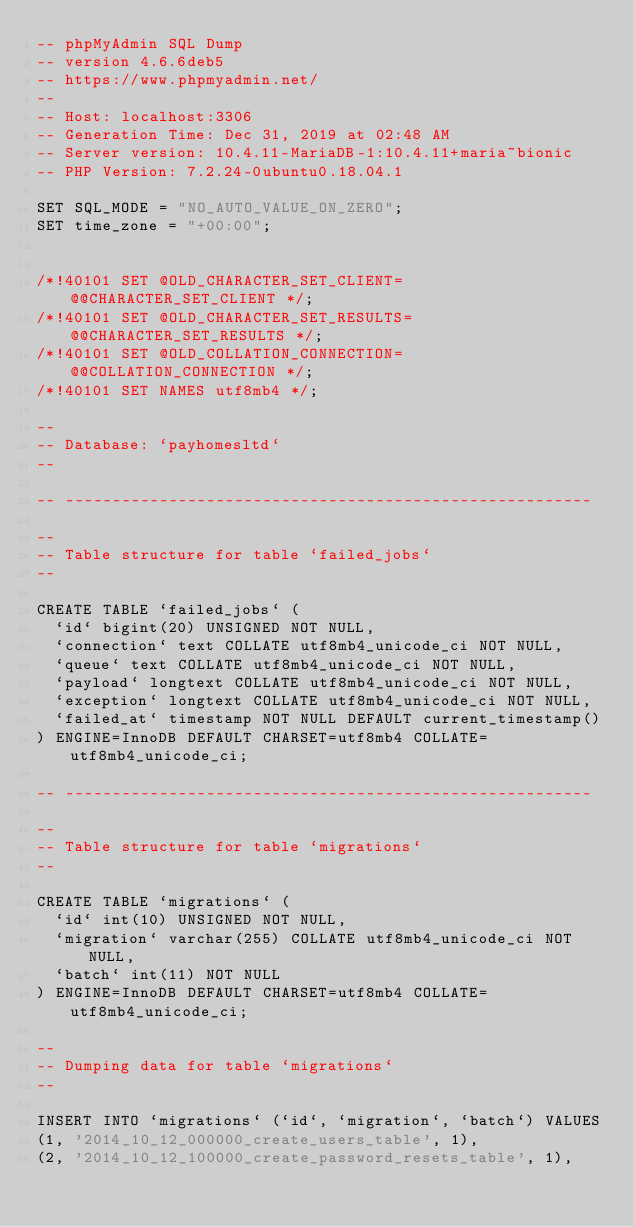<code> <loc_0><loc_0><loc_500><loc_500><_SQL_>-- phpMyAdmin SQL Dump
-- version 4.6.6deb5
-- https://www.phpmyadmin.net/
--
-- Host: localhost:3306
-- Generation Time: Dec 31, 2019 at 02:48 AM
-- Server version: 10.4.11-MariaDB-1:10.4.11+maria~bionic
-- PHP Version: 7.2.24-0ubuntu0.18.04.1

SET SQL_MODE = "NO_AUTO_VALUE_ON_ZERO";
SET time_zone = "+00:00";


/*!40101 SET @OLD_CHARACTER_SET_CLIENT=@@CHARACTER_SET_CLIENT */;
/*!40101 SET @OLD_CHARACTER_SET_RESULTS=@@CHARACTER_SET_RESULTS */;
/*!40101 SET @OLD_COLLATION_CONNECTION=@@COLLATION_CONNECTION */;
/*!40101 SET NAMES utf8mb4 */;

--
-- Database: `payhomesltd`
--

-- --------------------------------------------------------

--
-- Table structure for table `failed_jobs`
--

CREATE TABLE `failed_jobs` (
  `id` bigint(20) UNSIGNED NOT NULL,
  `connection` text COLLATE utf8mb4_unicode_ci NOT NULL,
  `queue` text COLLATE utf8mb4_unicode_ci NOT NULL,
  `payload` longtext COLLATE utf8mb4_unicode_ci NOT NULL,
  `exception` longtext COLLATE utf8mb4_unicode_ci NOT NULL,
  `failed_at` timestamp NOT NULL DEFAULT current_timestamp()
) ENGINE=InnoDB DEFAULT CHARSET=utf8mb4 COLLATE=utf8mb4_unicode_ci;

-- --------------------------------------------------------

--
-- Table structure for table `migrations`
--

CREATE TABLE `migrations` (
  `id` int(10) UNSIGNED NOT NULL,
  `migration` varchar(255) COLLATE utf8mb4_unicode_ci NOT NULL,
  `batch` int(11) NOT NULL
) ENGINE=InnoDB DEFAULT CHARSET=utf8mb4 COLLATE=utf8mb4_unicode_ci;

--
-- Dumping data for table `migrations`
--

INSERT INTO `migrations` (`id`, `migration`, `batch`) VALUES
(1, '2014_10_12_000000_create_users_table', 1),
(2, '2014_10_12_100000_create_password_resets_table', 1),</code> 